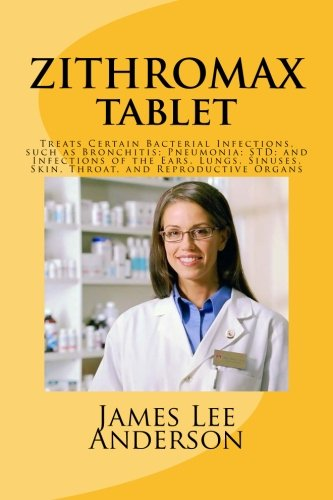Is this a fitness book? No, this book is not centered on fitness; it primarily deals with medical information concerning Zithromax, an antibiotic used to treat bacterial infections. 